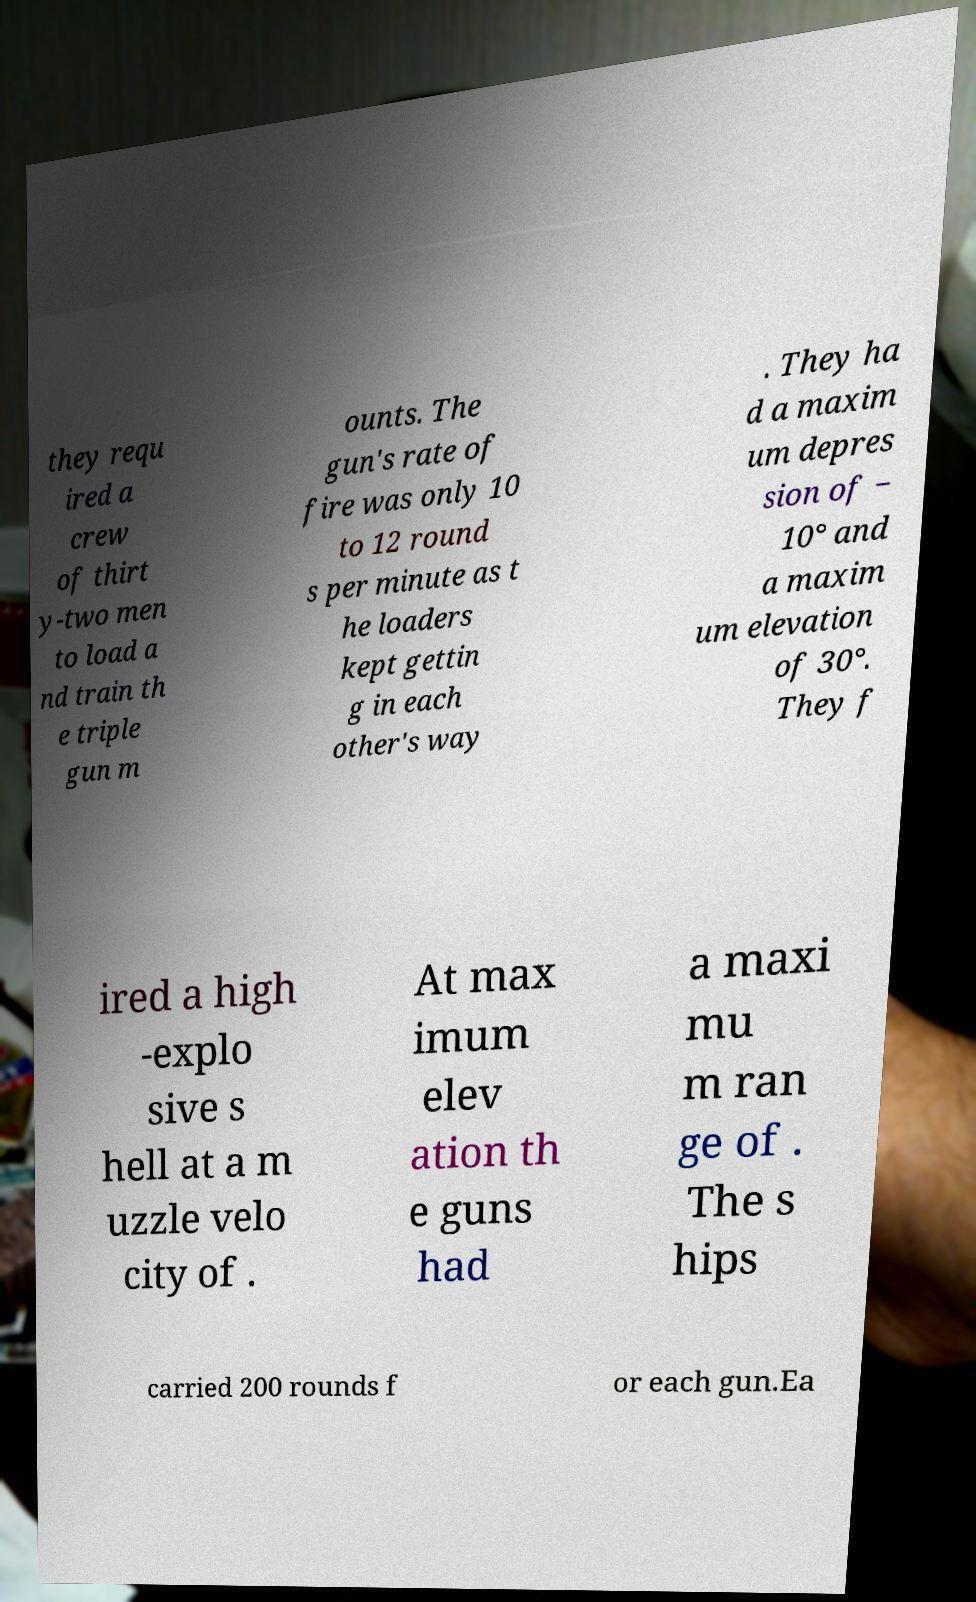Please identify and transcribe the text found in this image. they requ ired a crew of thirt y-two men to load a nd train th e triple gun m ounts. The gun's rate of fire was only 10 to 12 round s per minute as t he loaders kept gettin g in each other's way . They ha d a maxim um depres sion of − 10° and a maxim um elevation of 30°. They f ired a high -explo sive s hell at a m uzzle velo city of . At max imum elev ation th e guns had a maxi mu m ran ge of . The s hips carried 200 rounds f or each gun.Ea 